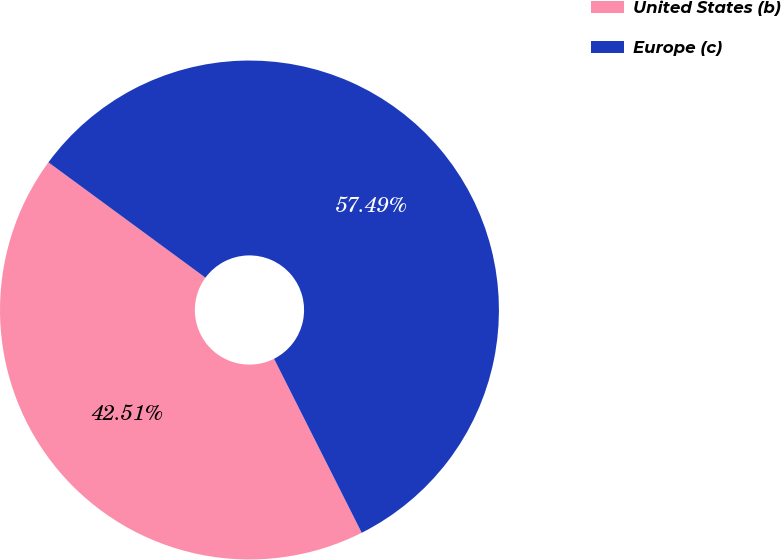Convert chart to OTSL. <chart><loc_0><loc_0><loc_500><loc_500><pie_chart><fcel>United States (b)<fcel>Europe (c)<nl><fcel>42.51%<fcel>57.49%<nl></chart> 